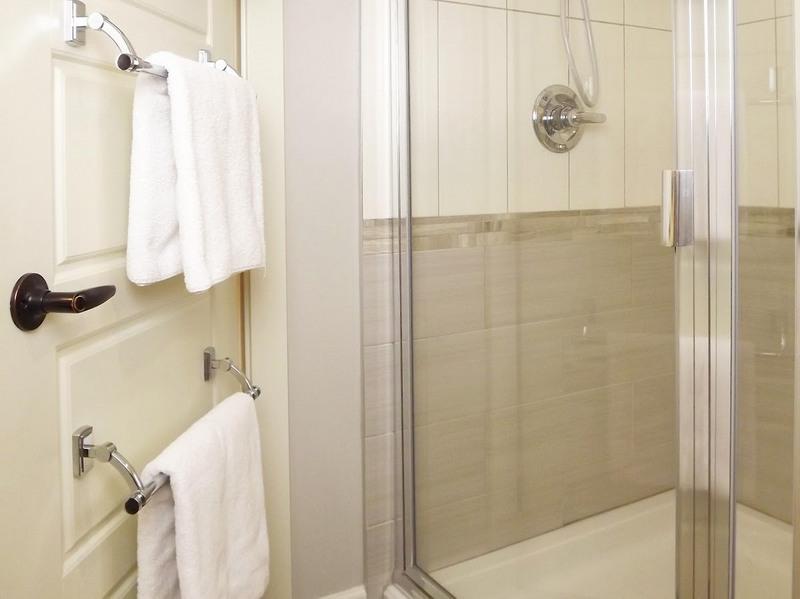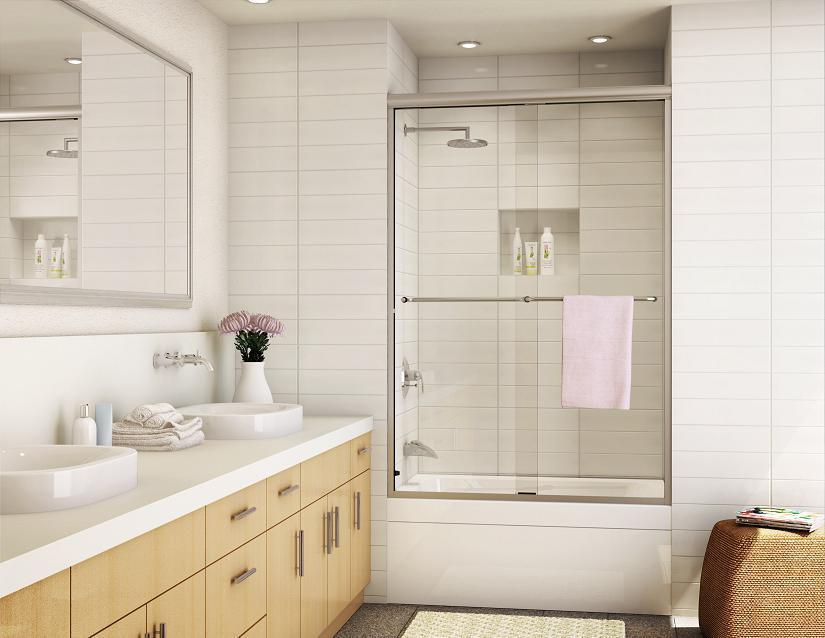The first image is the image on the left, the second image is the image on the right. Examine the images to the left and right. Is the description "In the image to the right, there are flowers on the bathroom counter." accurate? Answer yes or no. Yes. 